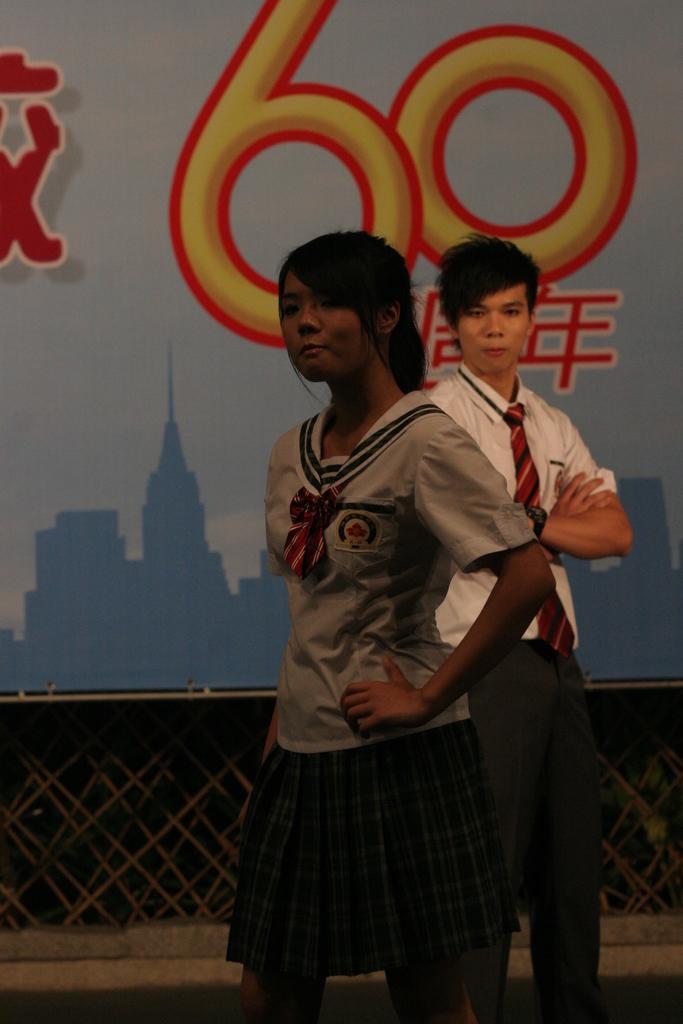Can you describe this image briefly? There is a woman and a man standing. In the back there is a wall with something written. 